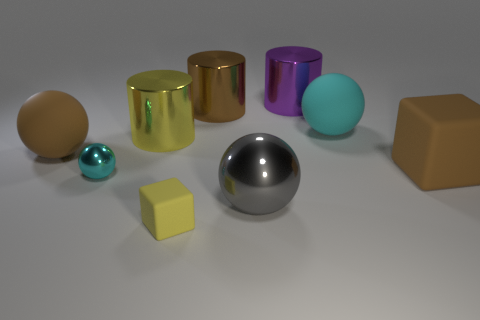What number of objects are either big rubber balls to the left of the purple metal thing or rubber objects that are on the right side of the purple metallic cylinder?
Ensure brevity in your answer.  3. Do the brown matte ball and the yellow cylinder have the same size?
Offer a very short reply. Yes. Are there any other things that are the same size as the purple object?
Offer a terse response. Yes. Does the gray thing right of the yellow cube have the same shape as the small object in front of the big metal sphere?
Ensure brevity in your answer.  No. The yellow cylinder is what size?
Make the answer very short. Large. What is the material of the yellow thing behind the cyan object that is to the left of the large ball that is right of the gray object?
Provide a succinct answer. Metal. What number of other objects are the same color as the small metal ball?
Your answer should be compact. 1. How many green objects are small spheres or large matte blocks?
Give a very brief answer. 0. There is a cyan sphere that is behind the big brown matte cube; what is it made of?
Your answer should be very brief. Rubber. Is the material of the cyan object that is in front of the big cube the same as the big yellow cylinder?
Your response must be concise. Yes. 